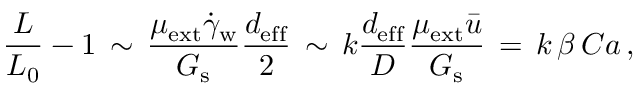<formula> <loc_0><loc_0><loc_500><loc_500>\frac { L } { L _ { 0 } } - 1 \, \sim \, \frac { \mu _ { e x t } \dot { \gamma } _ { w } } { G _ { s } } \frac { d _ { e f f } } { 2 } \, \sim \, k \frac { d _ { e f f } } { D } \frac { \mu _ { e x t } \bar { u } } { G _ { s } } \, = \, k \, \beta \, C a \, ,</formula> 